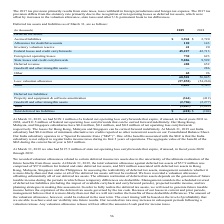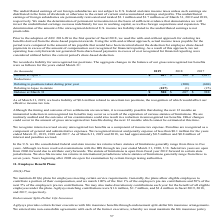According to Agilysys's financial document, What was the federal net operating loss carryforwards as at 31 March 2019? According to the financial document, $199.1 million. The relevant text states: "At March 31, 2019, we had $199.1 million of a federal net operating loss carryforwards that expire, if unused, in fiscal years 2031 to 2038,..." Also, What were the minimum alternative tax credits at India subsidiary in 2019? According to the financial document, $0.4 million. The relevant text states: "ng Kong, Malaysia, and Singapore subsidiaries have $0.4 million, $0.1 million, and $0.2 million of net operating loss carryforwards respectively. The losses for Ho..." Also, What were the accrued liabilities in 2019? According to the financial document, $3,944 (in thousands). The relevant text states: "Deferred tax assets: Accrued liabilities $ 3,944 $ 2,720..." Also, can you calculate: What was the average accrued liabilities for 2018 and 2019? To answer this question, I need to perform calculations using the financial data. The calculation is: (3,944 + 2,720) / 2, which equals 3332 (in thousands). This is based on the information: "Deferred tax assets: Accrued liabilities $ 3,944 $ 2,720 eferred tax assets: Accrued liabilities $ 3,944 $ 2,720..." The key data points involved are: 2,720, 3,944. Also, can you calculate: What was the percentage increase / (decrease) in allowance for doubtful accounts from 2018 to 2019? To answer this question, I need to perform calculations using the financial data. The calculation is: 120 / 143 - 1, which equals -16.08 (percentage). This is based on the information: "Allowance for doubtful accounts 120 143 Allowance for doubtful accounts 120 143..." The key data points involved are: 120, 143. Also, can you calculate: What was the increase / (decrease) in the inventory valuation reserve from 2018 to 2019? Based on the calculation: 41 - 20, the result is 21 (in thousands). This is based on the information: "Inventory valuation reserve 41 20 Inventory valuation reserve 41 20..." The key data points involved are: 20, 41. 